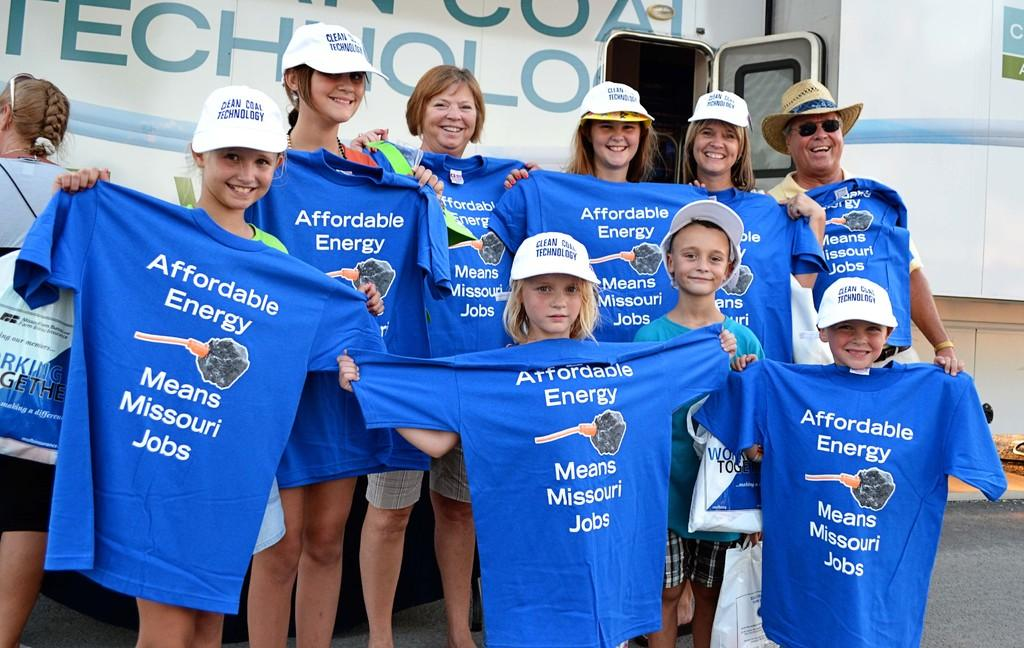<image>
Relay a brief, clear account of the picture shown. A group of adults and children holding shirts about affordable energy in Missouri. 